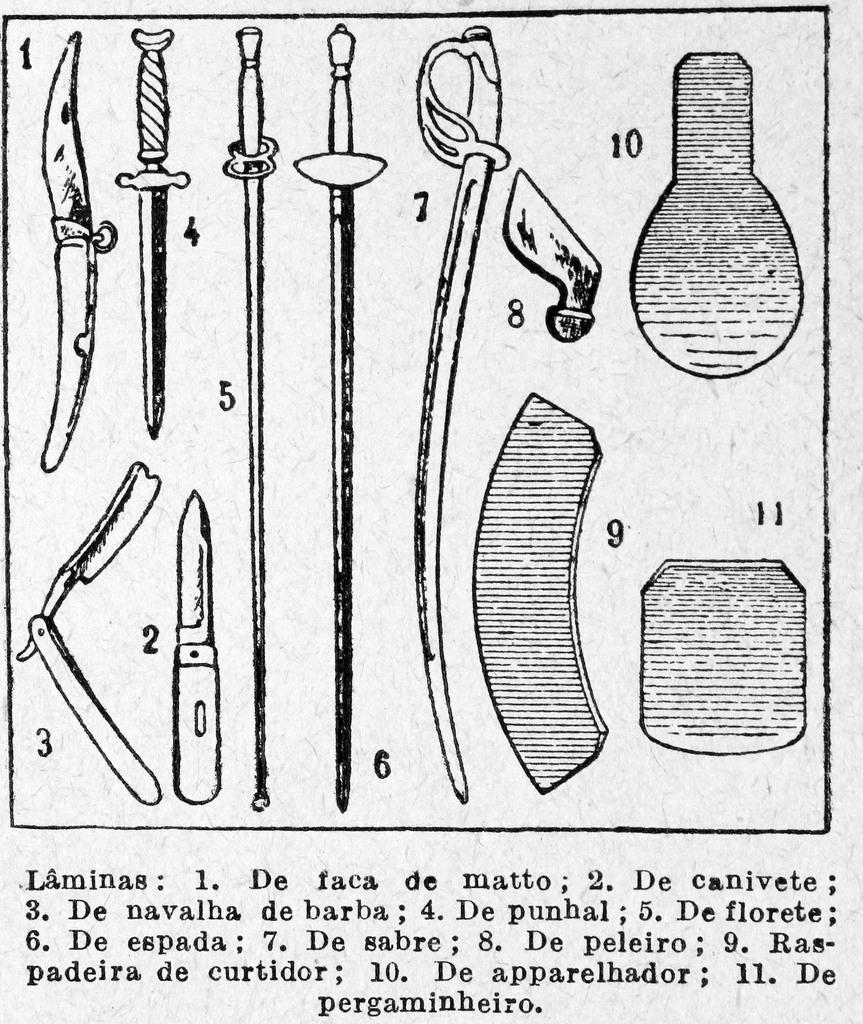What type of sharp objects are present in the image? There are knives and swords in the image. Are there any words written on the knives or swords? Yes, there are some words written on the knives or swords. Can you see any children playing on the mountain in the image? There is no mountain or children present in the image. Is there any indication of death or dying in the image? There is no indication of death or dying in the image; it only features knives and swords with words written on them. 